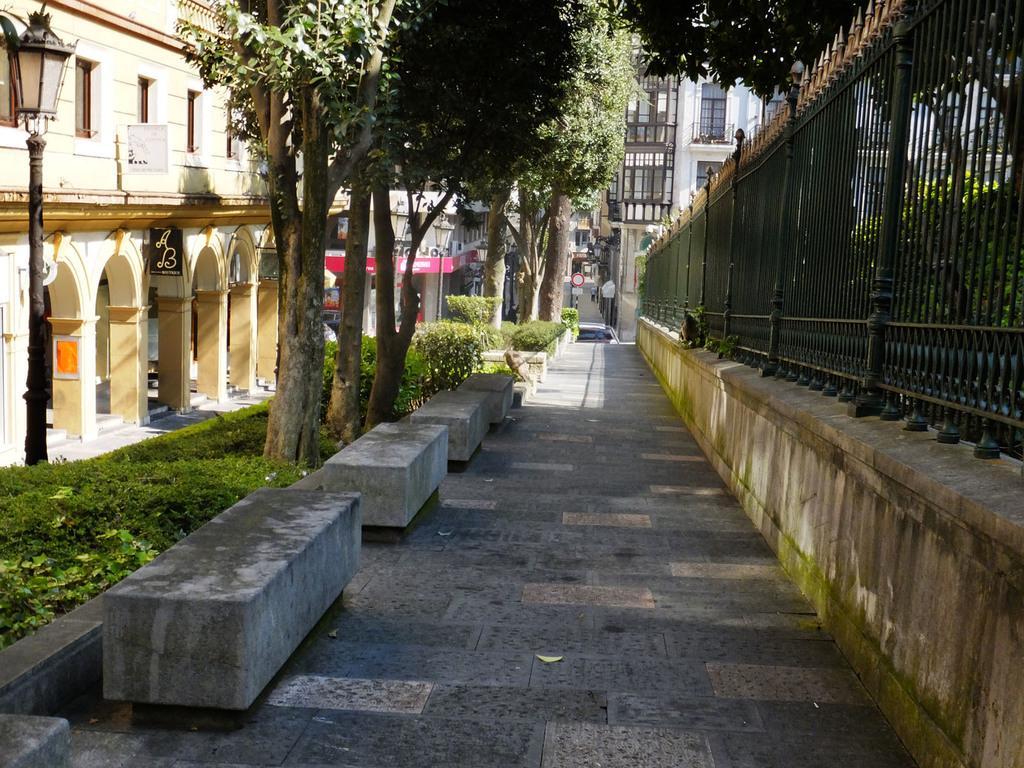In one or two sentences, can you explain what this image depicts? In this image we can see plants, trees, pillars, buildings, poles, lights, wall, railing, floor, stone platforms, and boards. 